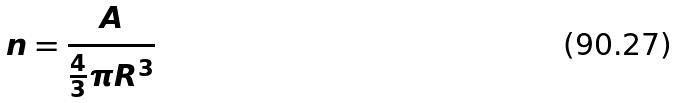<formula> <loc_0><loc_0><loc_500><loc_500>n = \frac { A } { \frac { 4 } { 3 } \pi R ^ { 3 } }</formula> 